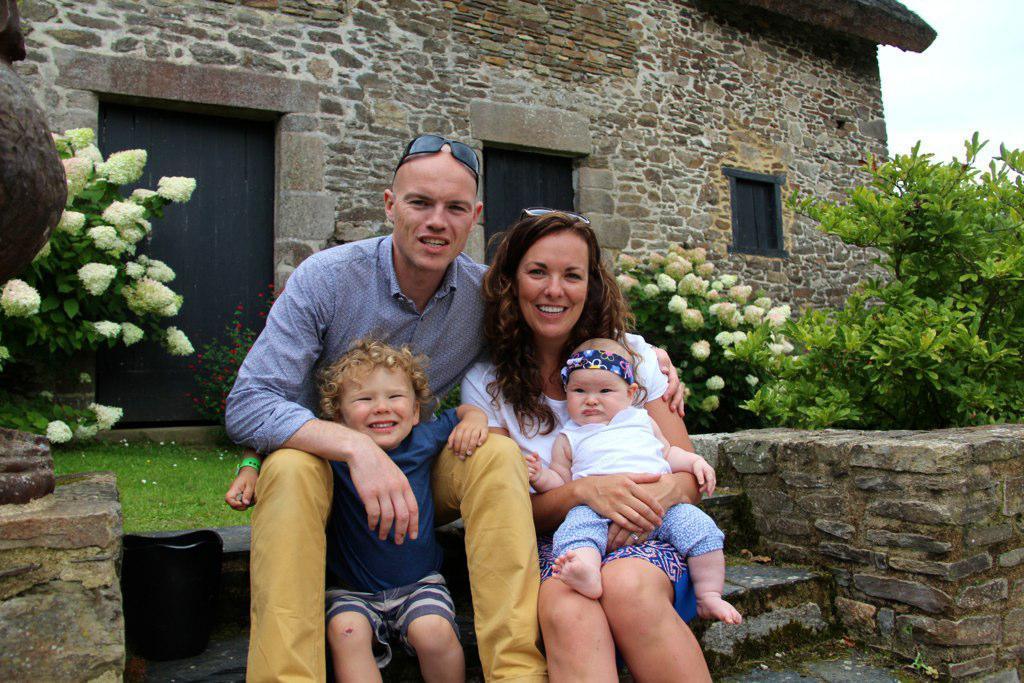Describe this image in one or two sentences. In this picture there is a man wearing blue color shirt is sitting with his wife and two children on the step, smiling and giving a pose into the camera. Behind there is a granite house with door and windows. On the right corner there are some white flowers and plants. 